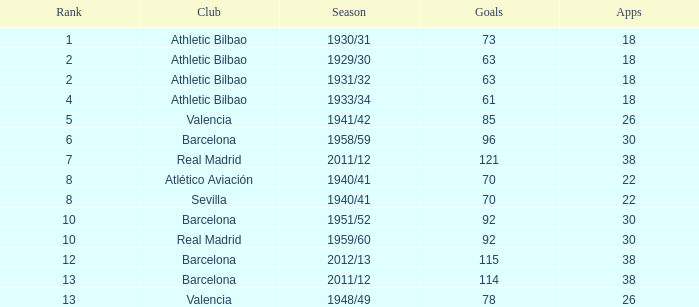In how many apps was the rank above 13 and the goal count exceeded 73? None. 